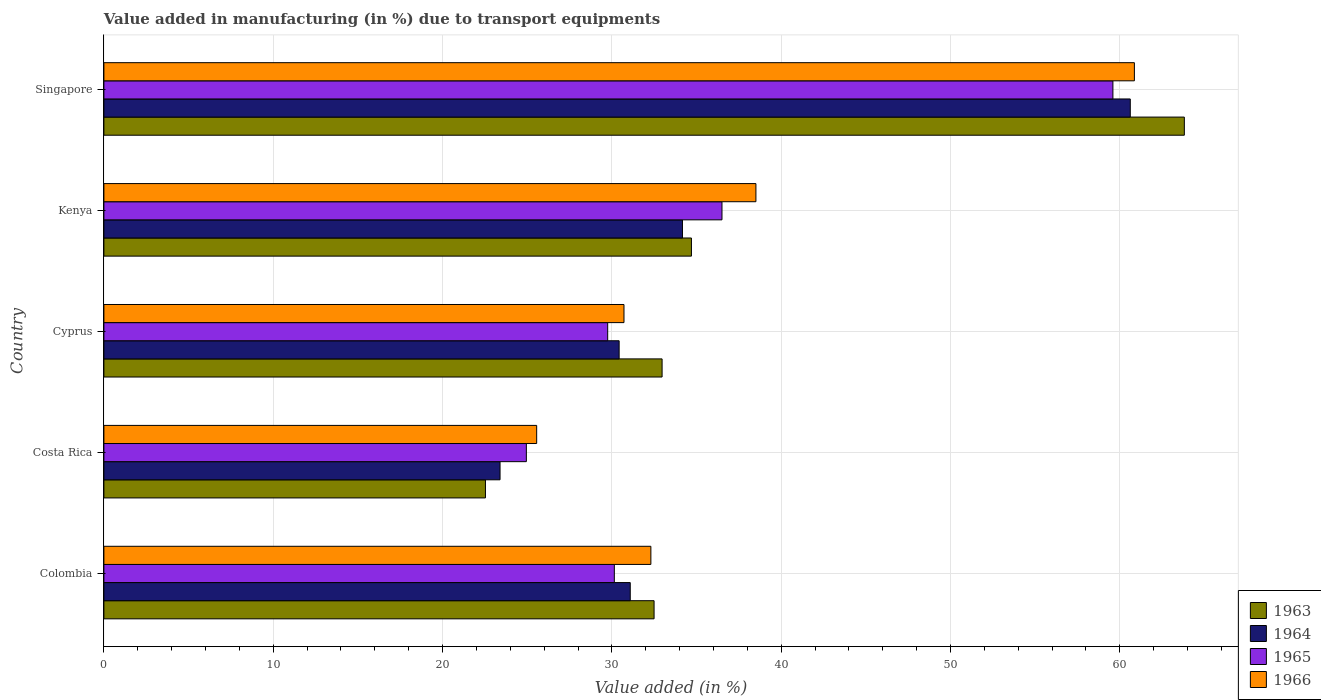Are the number of bars per tick equal to the number of legend labels?
Offer a terse response. Yes. How many bars are there on the 2nd tick from the top?
Ensure brevity in your answer.  4. What is the label of the 2nd group of bars from the top?
Keep it short and to the point. Kenya. What is the percentage of value added in manufacturing due to transport equipments in 1963 in Costa Rica?
Provide a short and direct response. 22.53. Across all countries, what is the maximum percentage of value added in manufacturing due to transport equipments in 1965?
Your response must be concise. 59.59. Across all countries, what is the minimum percentage of value added in manufacturing due to transport equipments in 1965?
Your answer should be very brief. 24.95. In which country was the percentage of value added in manufacturing due to transport equipments in 1965 maximum?
Keep it short and to the point. Singapore. In which country was the percentage of value added in manufacturing due to transport equipments in 1966 minimum?
Your answer should be compact. Costa Rica. What is the total percentage of value added in manufacturing due to transport equipments in 1966 in the graph?
Your answer should be very brief. 187.95. What is the difference between the percentage of value added in manufacturing due to transport equipments in 1964 in Colombia and that in Singapore?
Give a very brief answer. -29.53. What is the difference between the percentage of value added in manufacturing due to transport equipments in 1965 in Colombia and the percentage of value added in manufacturing due to transport equipments in 1963 in Singapore?
Ensure brevity in your answer.  -33.66. What is the average percentage of value added in manufacturing due to transport equipments in 1964 per country?
Offer a very short reply. 35.94. What is the difference between the percentage of value added in manufacturing due to transport equipments in 1963 and percentage of value added in manufacturing due to transport equipments in 1964 in Kenya?
Offer a terse response. 0.53. What is the ratio of the percentage of value added in manufacturing due to transport equipments in 1963 in Cyprus to that in Singapore?
Provide a succinct answer. 0.52. Is the percentage of value added in manufacturing due to transport equipments in 1965 in Colombia less than that in Cyprus?
Give a very brief answer. No. What is the difference between the highest and the second highest percentage of value added in manufacturing due to transport equipments in 1964?
Your answer should be very brief. 26.45. What is the difference between the highest and the lowest percentage of value added in manufacturing due to transport equipments in 1965?
Your answer should be compact. 34.64. In how many countries, is the percentage of value added in manufacturing due to transport equipments in 1966 greater than the average percentage of value added in manufacturing due to transport equipments in 1966 taken over all countries?
Offer a very short reply. 2. Is it the case that in every country, the sum of the percentage of value added in manufacturing due to transport equipments in 1964 and percentage of value added in manufacturing due to transport equipments in 1963 is greater than the sum of percentage of value added in manufacturing due to transport equipments in 1966 and percentage of value added in manufacturing due to transport equipments in 1965?
Offer a terse response. No. What does the 1st bar from the top in Cyprus represents?
Give a very brief answer. 1966. Are all the bars in the graph horizontal?
Provide a short and direct response. Yes. How many countries are there in the graph?
Offer a terse response. 5. What is the difference between two consecutive major ticks on the X-axis?
Ensure brevity in your answer.  10. Are the values on the major ticks of X-axis written in scientific E-notation?
Ensure brevity in your answer.  No. Does the graph contain any zero values?
Your response must be concise. No. How many legend labels are there?
Give a very brief answer. 4. How are the legend labels stacked?
Your answer should be compact. Vertical. What is the title of the graph?
Offer a very short reply. Value added in manufacturing (in %) due to transport equipments. Does "1968" appear as one of the legend labels in the graph?
Offer a very short reply. No. What is the label or title of the X-axis?
Ensure brevity in your answer.  Value added (in %). What is the Value added (in %) of 1963 in Colombia?
Your response must be concise. 32.49. What is the Value added (in %) of 1964 in Colombia?
Give a very brief answer. 31.09. What is the Value added (in %) of 1965 in Colombia?
Make the answer very short. 30.15. What is the Value added (in %) of 1966 in Colombia?
Make the answer very short. 32.3. What is the Value added (in %) of 1963 in Costa Rica?
Give a very brief answer. 22.53. What is the Value added (in %) of 1964 in Costa Rica?
Your response must be concise. 23.4. What is the Value added (in %) of 1965 in Costa Rica?
Give a very brief answer. 24.95. What is the Value added (in %) of 1966 in Costa Rica?
Keep it short and to the point. 25.56. What is the Value added (in %) in 1963 in Cyprus?
Keep it short and to the point. 32.97. What is the Value added (in %) of 1964 in Cyprus?
Ensure brevity in your answer.  30.43. What is the Value added (in %) in 1965 in Cyprus?
Keep it short and to the point. 29.75. What is the Value added (in %) in 1966 in Cyprus?
Provide a succinct answer. 30.72. What is the Value added (in %) of 1963 in Kenya?
Your answer should be very brief. 34.7. What is the Value added (in %) in 1964 in Kenya?
Make the answer very short. 34.17. What is the Value added (in %) in 1965 in Kenya?
Provide a short and direct response. 36.5. What is the Value added (in %) in 1966 in Kenya?
Your answer should be compact. 38.51. What is the Value added (in %) in 1963 in Singapore?
Your answer should be very brief. 63.81. What is the Value added (in %) of 1964 in Singapore?
Your response must be concise. 60.62. What is the Value added (in %) in 1965 in Singapore?
Keep it short and to the point. 59.59. What is the Value added (in %) of 1966 in Singapore?
Give a very brief answer. 60.86. Across all countries, what is the maximum Value added (in %) of 1963?
Your answer should be compact. 63.81. Across all countries, what is the maximum Value added (in %) of 1964?
Your response must be concise. 60.62. Across all countries, what is the maximum Value added (in %) in 1965?
Your response must be concise. 59.59. Across all countries, what is the maximum Value added (in %) in 1966?
Your answer should be very brief. 60.86. Across all countries, what is the minimum Value added (in %) in 1963?
Make the answer very short. 22.53. Across all countries, what is the minimum Value added (in %) in 1964?
Keep it short and to the point. 23.4. Across all countries, what is the minimum Value added (in %) of 1965?
Provide a succinct answer. 24.95. Across all countries, what is the minimum Value added (in %) in 1966?
Provide a succinct answer. 25.56. What is the total Value added (in %) of 1963 in the graph?
Provide a short and direct response. 186.5. What is the total Value added (in %) in 1964 in the graph?
Offer a terse response. 179.7. What is the total Value added (in %) of 1965 in the graph?
Ensure brevity in your answer.  180.94. What is the total Value added (in %) of 1966 in the graph?
Your answer should be very brief. 187.95. What is the difference between the Value added (in %) in 1963 in Colombia and that in Costa Rica?
Give a very brief answer. 9.96. What is the difference between the Value added (in %) in 1964 in Colombia and that in Costa Rica?
Keep it short and to the point. 7.69. What is the difference between the Value added (in %) in 1965 in Colombia and that in Costa Rica?
Your answer should be very brief. 5.2. What is the difference between the Value added (in %) of 1966 in Colombia and that in Costa Rica?
Ensure brevity in your answer.  6.74. What is the difference between the Value added (in %) in 1963 in Colombia and that in Cyprus?
Give a very brief answer. -0.47. What is the difference between the Value added (in %) in 1964 in Colombia and that in Cyprus?
Your answer should be very brief. 0.66. What is the difference between the Value added (in %) of 1965 in Colombia and that in Cyprus?
Offer a terse response. 0.39. What is the difference between the Value added (in %) in 1966 in Colombia and that in Cyprus?
Offer a very short reply. 1.59. What is the difference between the Value added (in %) of 1963 in Colombia and that in Kenya?
Your answer should be compact. -2.21. What is the difference between the Value added (in %) in 1964 in Colombia and that in Kenya?
Ensure brevity in your answer.  -3.08. What is the difference between the Value added (in %) in 1965 in Colombia and that in Kenya?
Offer a very short reply. -6.36. What is the difference between the Value added (in %) of 1966 in Colombia and that in Kenya?
Offer a very short reply. -6.2. What is the difference between the Value added (in %) of 1963 in Colombia and that in Singapore?
Your response must be concise. -31.32. What is the difference between the Value added (in %) in 1964 in Colombia and that in Singapore?
Give a very brief answer. -29.53. What is the difference between the Value added (in %) of 1965 in Colombia and that in Singapore?
Your answer should be compact. -29.45. What is the difference between the Value added (in %) in 1966 in Colombia and that in Singapore?
Ensure brevity in your answer.  -28.56. What is the difference between the Value added (in %) of 1963 in Costa Rica and that in Cyprus?
Give a very brief answer. -10.43. What is the difference between the Value added (in %) in 1964 in Costa Rica and that in Cyprus?
Your answer should be compact. -7.03. What is the difference between the Value added (in %) of 1965 in Costa Rica and that in Cyprus?
Your answer should be very brief. -4.8. What is the difference between the Value added (in %) in 1966 in Costa Rica and that in Cyprus?
Offer a terse response. -5.16. What is the difference between the Value added (in %) of 1963 in Costa Rica and that in Kenya?
Offer a terse response. -12.17. What is the difference between the Value added (in %) of 1964 in Costa Rica and that in Kenya?
Keep it short and to the point. -10.77. What is the difference between the Value added (in %) of 1965 in Costa Rica and that in Kenya?
Make the answer very short. -11.55. What is the difference between the Value added (in %) in 1966 in Costa Rica and that in Kenya?
Offer a very short reply. -12.95. What is the difference between the Value added (in %) in 1963 in Costa Rica and that in Singapore?
Offer a very short reply. -41.28. What is the difference between the Value added (in %) of 1964 in Costa Rica and that in Singapore?
Your answer should be compact. -37.22. What is the difference between the Value added (in %) in 1965 in Costa Rica and that in Singapore?
Make the answer very short. -34.64. What is the difference between the Value added (in %) of 1966 in Costa Rica and that in Singapore?
Your answer should be very brief. -35.3. What is the difference between the Value added (in %) of 1963 in Cyprus and that in Kenya?
Ensure brevity in your answer.  -1.73. What is the difference between the Value added (in %) of 1964 in Cyprus and that in Kenya?
Provide a short and direct response. -3.74. What is the difference between the Value added (in %) of 1965 in Cyprus and that in Kenya?
Offer a terse response. -6.75. What is the difference between the Value added (in %) in 1966 in Cyprus and that in Kenya?
Your response must be concise. -7.79. What is the difference between the Value added (in %) in 1963 in Cyprus and that in Singapore?
Offer a very short reply. -30.84. What is the difference between the Value added (in %) in 1964 in Cyprus and that in Singapore?
Provide a short and direct response. -30.19. What is the difference between the Value added (in %) in 1965 in Cyprus and that in Singapore?
Give a very brief answer. -29.84. What is the difference between the Value added (in %) of 1966 in Cyprus and that in Singapore?
Offer a terse response. -30.14. What is the difference between the Value added (in %) in 1963 in Kenya and that in Singapore?
Give a very brief answer. -29.11. What is the difference between the Value added (in %) in 1964 in Kenya and that in Singapore?
Ensure brevity in your answer.  -26.45. What is the difference between the Value added (in %) of 1965 in Kenya and that in Singapore?
Your answer should be very brief. -23.09. What is the difference between the Value added (in %) of 1966 in Kenya and that in Singapore?
Provide a short and direct response. -22.35. What is the difference between the Value added (in %) in 1963 in Colombia and the Value added (in %) in 1964 in Costa Rica?
Ensure brevity in your answer.  9.1. What is the difference between the Value added (in %) of 1963 in Colombia and the Value added (in %) of 1965 in Costa Rica?
Provide a short and direct response. 7.54. What is the difference between the Value added (in %) of 1963 in Colombia and the Value added (in %) of 1966 in Costa Rica?
Provide a succinct answer. 6.93. What is the difference between the Value added (in %) in 1964 in Colombia and the Value added (in %) in 1965 in Costa Rica?
Make the answer very short. 6.14. What is the difference between the Value added (in %) of 1964 in Colombia and the Value added (in %) of 1966 in Costa Rica?
Your answer should be compact. 5.53. What is the difference between the Value added (in %) of 1965 in Colombia and the Value added (in %) of 1966 in Costa Rica?
Provide a succinct answer. 4.59. What is the difference between the Value added (in %) in 1963 in Colombia and the Value added (in %) in 1964 in Cyprus?
Keep it short and to the point. 2.06. What is the difference between the Value added (in %) of 1963 in Colombia and the Value added (in %) of 1965 in Cyprus?
Keep it short and to the point. 2.74. What is the difference between the Value added (in %) of 1963 in Colombia and the Value added (in %) of 1966 in Cyprus?
Make the answer very short. 1.78. What is the difference between the Value added (in %) in 1964 in Colombia and the Value added (in %) in 1965 in Cyprus?
Keep it short and to the point. 1.33. What is the difference between the Value added (in %) of 1964 in Colombia and the Value added (in %) of 1966 in Cyprus?
Offer a very short reply. 0.37. What is the difference between the Value added (in %) in 1965 in Colombia and the Value added (in %) in 1966 in Cyprus?
Offer a very short reply. -0.57. What is the difference between the Value added (in %) in 1963 in Colombia and the Value added (in %) in 1964 in Kenya?
Ensure brevity in your answer.  -1.68. What is the difference between the Value added (in %) in 1963 in Colombia and the Value added (in %) in 1965 in Kenya?
Your response must be concise. -4.01. What is the difference between the Value added (in %) in 1963 in Colombia and the Value added (in %) in 1966 in Kenya?
Keep it short and to the point. -6.01. What is the difference between the Value added (in %) in 1964 in Colombia and the Value added (in %) in 1965 in Kenya?
Give a very brief answer. -5.42. What is the difference between the Value added (in %) of 1964 in Colombia and the Value added (in %) of 1966 in Kenya?
Offer a very short reply. -7.42. What is the difference between the Value added (in %) in 1965 in Colombia and the Value added (in %) in 1966 in Kenya?
Your answer should be very brief. -8.36. What is the difference between the Value added (in %) in 1963 in Colombia and the Value added (in %) in 1964 in Singapore?
Provide a succinct answer. -28.12. What is the difference between the Value added (in %) in 1963 in Colombia and the Value added (in %) in 1965 in Singapore?
Provide a short and direct response. -27.1. What is the difference between the Value added (in %) of 1963 in Colombia and the Value added (in %) of 1966 in Singapore?
Give a very brief answer. -28.37. What is the difference between the Value added (in %) in 1964 in Colombia and the Value added (in %) in 1965 in Singapore?
Keep it short and to the point. -28.51. What is the difference between the Value added (in %) in 1964 in Colombia and the Value added (in %) in 1966 in Singapore?
Offer a very short reply. -29.77. What is the difference between the Value added (in %) in 1965 in Colombia and the Value added (in %) in 1966 in Singapore?
Keep it short and to the point. -30.71. What is the difference between the Value added (in %) in 1963 in Costa Rica and the Value added (in %) in 1964 in Cyprus?
Offer a very short reply. -7.9. What is the difference between the Value added (in %) in 1963 in Costa Rica and the Value added (in %) in 1965 in Cyprus?
Make the answer very short. -7.22. What is the difference between the Value added (in %) in 1963 in Costa Rica and the Value added (in %) in 1966 in Cyprus?
Make the answer very short. -8.18. What is the difference between the Value added (in %) in 1964 in Costa Rica and the Value added (in %) in 1965 in Cyprus?
Ensure brevity in your answer.  -6.36. What is the difference between the Value added (in %) of 1964 in Costa Rica and the Value added (in %) of 1966 in Cyprus?
Ensure brevity in your answer.  -7.32. What is the difference between the Value added (in %) in 1965 in Costa Rica and the Value added (in %) in 1966 in Cyprus?
Provide a short and direct response. -5.77. What is the difference between the Value added (in %) in 1963 in Costa Rica and the Value added (in %) in 1964 in Kenya?
Provide a short and direct response. -11.64. What is the difference between the Value added (in %) in 1963 in Costa Rica and the Value added (in %) in 1965 in Kenya?
Ensure brevity in your answer.  -13.97. What is the difference between the Value added (in %) in 1963 in Costa Rica and the Value added (in %) in 1966 in Kenya?
Provide a succinct answer. -15.97. What is the difference between the Value added (in %) of 1964 in Costa Rica and the Value added (in %) of 1965 in Kenya?
Offer a terse response. -13.11. What is the difference between the Value added (in %) in 1964 in Costa Rica and the Value added (in %) in 1966 in Kenya?
Provide a short and direct response. -15.11. What is the difference between the Value added (in %) in 1965 in Costa Rica and the Value added (in %) in 1966 in Kenya?
Offer a terse response. -13.56. What is the difference between the Value added (in %) of 1963 in Costa Rica and the Value added (in %) of 1964 in Singapore?
Make the answer very short. -38.08. What is the difference between the Value added (in %) of 1963 in Costa Rica and the Value added (in %) of 1965 in Singapore?
Your answer should be very brief. -37.06. What is the difference between the Value added (in %) of 1963 in Costa Rica and the Value added (in %) of 1966 in Singapore?
Give a very brief answer. -38.33. What is the difference between the Value added (in %) in 1964 in Costa Rica and the Value added (in %) in 1965 in Singapore?
Make the answer very short. -36.19. What is the difference between the Value added (in %) in 1964 in Costa Rica and the Value added (in %) in 1966 in Singapore?
Offer a very short reply. -37.46. What is the difference between the Value added (in %) of 1965 in Costa Rica and the Value added (in %) of 1966 in Singapore?
Ensure brevity in your answer.  -35.91. What is the difference between the Value added (in %) in 1963 in Cyprus and the Value added (in %) in 1964 in Kenya?
Your answer should be very brief. -1.2. What is the difference between the Value added (in %) of 1963 in Cyprus and the Value added (in %) of 1965 in Kenya?
Your answer should be compact. -3.54. What is the difference between the Value added (in %) in 1963 in Cyprus and the Value added (in %) in 1966 in Kenya?
Your answer should be very brief. -5.54. What is the difference between the Value added (in %) in 1964 in Cyprus and the Value added (in %) in 1965 in Kenya?
Provide a short and direct response. -6.07. What is the difference between the Value added (in %) of 1964 in Cyprus and the Value added (in %) of 1966 in Kenya?
Provide a short and direct response. -8.08. What is the difference between the Value added (in %) in 1965 in Cyprus and the Value added (in %) in 1966 in Kenya?
Provide a succinct answer. -8.75. What is the difference between the Value added (in %) in 1963 in Cyprus and the Value added (in %) in 1964 in Singapore?
Ensure brevity in your answer.  -27.65. What is the difference between the Value added (in %) in 1963 in Cyprus and the Value added (in %) in 1965 in Singapore?
Provide a succinct answer. -26.62. What is the difference between the Value added (in %) in 1963 in Cyprus and the Value added (in %) in 1966 in Singapore?
Provide a succinct answer. -27.89. What is the difference between the Value added (in %) of 1964 in Cyprus and the Value added (in %) of 1965 in Singapore?
Offer a very short reply. -29.16. What is the difference between the Value added (in %) in 1964 in Cyprus and the Value added (in %) in 1966 in Singapore?
Ensure brevity in your answer.  -30.43. What is the difference between the Value added (in %) in 1965 in Cyprus and the Value added (in %) in 1966 in Singapore?
Make the answer very short. -31.11. What is the difference between the Value added (in %) in 1963 in Kenya and the Value added (in %) in 1964 in Singapore?
Provide a succinct answer. -25.92. What is the difference between the Value added (in %) of 1963 in Kenya and the Value added (in %) of 1965 in Singapore?
Offer a very short reply. -24.89. What is the difference between the Value added (in %) in 1963 in Kenya and the Value added (in %) in 1966 in Singapore?
Provide a short and direct response. -26.16. What is the difference between the Value added (in %) in 1964 in Kenya and the Value added (in %) in 1965 in Singapore?
Your answer should be compact. -25.42. What is the difference between the Value added (in %) in 1964 in Kenya and the Value added (in %) in 1966 in Singapore?
Offer a terse response. -26.69. What is the difference between the Value added (in %) of 1965 in Kenya and the Value added (in %) of 1966 in Singapore?
Give a very brief answer. -24.36. What is the average Value added (in %) in 1963 per country?
Provide a short and direct response. 37.3. What is the average Value added (in %) in 1964 per country?
Ensure brevity in your answer.  35.94. What is the average Value added (in %) in 1965 per country?
Offer a very short reply. 36.19. What is the average Value added (in %) in 1966 per country?
Provide a succinct answer. 37.59. What is the difference between the Value added (in %) of 1963 and Value added (in %) of 1964 in Colombia?
Your answer should be compact. 1.41. What is the difference between the Value added (in %) of 1963 and Value added (in %) of 1965 in Colombia?
Your answer should be compact. 2.35. What is the difference between the Value added (in %) of 1963 and Value added (in %) of 1966 in Colombia?
Ensure brevity in your answer.  0.19. What is the difference between the Value added (in %) of 1964 and Value added (in %) of 1965 in Colombia?
Your response must be concise. 0.94. What is the difference between the Value added (in %) in 1964 and Value added (in %) in 1966 in Colombia?
Provide a short and direct response. -1.22. What is the difference between the Value added (in %) of 1965 and Value added (in %) of 1966 in Colombia?
Your response must be concise. -2.16. What is the difference between the Value added (in %) in 1963 and Value added (in %) in 1964 in Costa Rica?
Provide a short and direct response. -0.86. What is the difference between the Value added (in %) of 1963 and Value added (in %) of 1965 in Costa Rica?
Ensure brevity in your answer.  -2.42. What is the difference between the Value added (in %) in 1963 and Value added (in %) in 1966 in Costa Rica?
Your answer should be compact. -3.03. What is the difference between the Value added (in %) in 1964 and Value added (in %) in 1965 in Costa Rica?
Provide a short and direct response. -1.55. What is the difference between the Value added (in %) in 1964 and Value added (in %) in 1966 in Costa Rica?
Ensure brevity in your answer.  -2.16. What is the difference between the Value added (in %) in 1965 and Value added (in %) in 1966 in Costa Rica?
Your response must be concise. -0.61. What is the difference between the Value added (in %) of 1963 and Value added (in %) of 1964 in Cyprus?
Provide a short and direct response. 2.54. What is the difference between the Value added (in %) in 1963 and Value added (in %) in 1965 in Cyprus?
Provide a succinct answer. 3.21. What is the difference between the Value added (in %) of 1963 and Value added (in %) of 1966 in Cyprus?
Provide a short and direct response. 2.25. What is the difference between the Value added (in %) in 1964 and Value added (in %) in 1965 in Cyprus?
Give a very brief answer. 0.68. What is the difference between the Value added (in %) of 1964 and Value added (in %) of 1966 in Cyprus?
Offer a very short reply. -0.29. What is the difference between the Value added (in %) in 1965 and Value added (in %) in 1966 in Cyprus?
Your response must be concise. -0.96. What is the difference between the Value added (in %) of 1963 and Value added (in %) of 1964 in Kenya?
Provide a succinct answer. 0.53. What is the difference between the Value added (in %) of 1963 and Value added (in %) of 1965 in Kenya?
Your answer should be very brief. -1.8. What is the difference between the Value added (in %) of 1963 and Value added (in %) of 1966 in Kenya?
Give a very brief answer. -3.81. What is the difference between the Value added (in %) in 1964 and Value added (in %) in 1965 in Kenya?
Ensure brevity in your answer.  -2.33. What is the difference between the Value added (in %) of 1964 and Value added (in %) of 1966 in Kenya?
Keep it short and to the point. -4.34. What is the difference between the Value added (in %) of 1965 and Value added (in %) of 1966 in Kenya?
Keep it short and to the point. -2. What is the difference between the Value added (in %) in 1963 and Value added (in %) in 1964 in Singapore?
Your response must be concise. 3.19. What is the difference between the Value added (in %) of 1963 and Value added (in %) of 1965 in Singapore?
Give a very brief answer. 4.22. What is the difference between the Value added (in %) in 1963 and Value added (in %) in 1966 in Singapore?
Your response must be concise. 2.95. What is the difference between the Value added (in %) in 1964 and Value added (in %) in 1965 in Singapore?
Your answer should be very brief. 1.03. What is the difference between the Value added (in %) of 1964 and Value added (in %) of 1966 in Singapore?
Provide a succinct answer. -0.24. What is the difference between the Value added (in %) of 1965 and Value added (in %) of 1966 in Singapore?
Keep it short and to the point. -1.27. What is the ratio of the Value added (in %) of 1963 in Colombia to that in Costa Rica?
Give a very brief answer. 1.44. What is the ratio of the Value added (in %) of 1964 in Colombia to that in Costa Rica?
Ensure brevity in your answer.  1.33. What is the ratio of the Value added (in %) of 1965 in Colombia to that in Costa Rica?
Offer a very short reply. 1.21. What is the ratio of the Value added (in %) in 1966 in Colombia to that in Costa Rica?
Provide a short and direct response. 1.26. What is the ratio of the Value added (in %) of 1963 in Colombia to that in Cyprus?
Give a very brief answer. 0.99. What is the ratio of the Value added (in %) of 1964 in Colombia to that in Cyprus?
Provide a succinct answer. 1.02. What is the ratio of the Value added (in %) of 1965 in Colombia to that in Cyprus?
Your answer should be very brief. 1.01. What is the ratio of the Value added (in %) of 1966 in Colombia to that in Cyprus?
Offer a terse response. 1.05. What is the ratio of the Value added (in %) in 1963 in Colombia to that in Kenya?
Your response must be concise. 0.94. What is the ratio of the Value added (in %) of 1964 in Colombia to that in Kenya?
Make the answer very short. 0.91. What is the ratio of the Value added (in %) of 1965 in Colombia to that in Kenya?
Keep it short and to the point. 0.83. What is the ratio of the Value added (in %) in 1966 in Colombia to that in Kenya?
Your answer should be compact. 0.84. What is the ratio of the Value added (in %) of 1963 in Colombia to that in Singapore?
Provide a succinct answer. 0.51. What is the ratio of the Value added (in %) in 1964 in Colombia to that in Singapore?
Make the answer very short. 0.51. What is the ratio of the Value added (in %) of 1965 in Colombia to that in Singapore?
Offer a very short reply. 0.51. What is the ratio of the Value added (in %) of 1966 in Colombia to that in Singapore?
Your response must be concise. 0.53. What is the ratio of the Value added (in %) of 1963 in Costa Rica to that in Cyprus?
Your response must be concise. 0.68. What is the ratio of the Value added (in %) of 1964 in Costa Rica to that in Cyprus?
Provide a succinct answer. 0.77. What is the ratio of the Value added (in %) of 1965 in Costa Rica to that in Cyprus?
Offer a terse response. 0.84. What is the ratio of the Value added (in %) in 1966 in Costa Rica to that in Cyprus?
Provide a succinct answer. 0.83. What is the ratio of the Value added (in %) of 1963 in Costa Rica to that in Kenya?
Offer a terse response. 0.65. What is the ratio of the Value added (in %) of 1964 in Costa Rica to that in Kenya?
Provide a succinct answer. 0.68. What is the ratio of the Value added (in %) in 1965 in Costa Rica to that in Kenya?
Your answer should be very brief. 0.68. What is the ratio of the Value added (in %) of 1966 in Costa Rica to that in Kenya?
Offer a terse response. 0.66. What is the ratio of the Value added (in %) in 1963 in Costa Rica to that in Singapore?
Your answer should be very brief. 0.35. What is the ratio of the Value added (in %) of 1964 in Costa Rica to that in Singapore?
Offer a very short reply. 0.39. What is the ratio of the Value added (in %) in 1965 in Costa Rica to that in Singapore?
Keep it short and to the point. 0.42. What is the ratio of the Value added (in %) in 1966 in Costa Rica to that in Singapore?
Provide a succinct answer. 0.42. What is the ratio of the Value added (in %) of 1963 in Cyprus to that in Kenya?
Make the answer very short. 0.95. What is the ratio of the Value added (in %) of 1964 in Cyprus to that in Kenya?
Offer a terse response. 0.89. What is the ratio of the Value added (in %) of 1965 in Cyprus to that in Kenya?
Your answer should be very brief. 0.82. What is the ratio of the Value added (in %) in 1966 in Cyprus to that in Kenya?
Ensure brevity in your answer.  0.8. What is the ratio of the Value added (in %) in 1963 in Cyprus to that in Singapore?
Provide a succinct answer. 0.52. What is the ratio of the Value added (in %) in 1964 in Cyprus to that in Singapore?
Your answer should be compact. 0.5. What is the ratio of the Value added (in %) in 1965 in Cyprus to that in Singapore?
Offer a terse response. 0.5. What is the ratio of the Value added (in %) in 1966 in Cyprus to that in Singapore?
Provide a succinct answer. 0.5. What is the ratio of the Value added (in %) of 1963 in Kenya to that in Singapore?
Your answer should be compact. 0.54. What is the ratio of the Value added (in %) of 1964 in Kenya to that in Singapore?
Give a very brief answer. 0.56. What is the ratio of the Value added (in %) in 1965 in Kenya to that in Singapore?
Offer a very short reply. 0.61. What is the ratio of the Value added (in %) in 1966 in Kenya to that in Singapore?
Ensure brevity in your answer.  0.63. What is the difference between the highest and the second highest Value added (in %) in 1963?
Your response must be concise. 29.11. What is the difference between the highest and the second highest Value added (in %) of 1964?
Provide a succinct answer. 26.45. What is the difference between the highest and the second highest Value added (in %) of 1965?
Offer a very short reply. 23.09. What is the difference between the highest and the second highest Value added (in %) of 1966?
Provide a succinct answer. 22.35. What is the difference between the highest and the lowest Value added (in %) in 1963?
Your answer should be very brief. 41.28. What is the difference between the highest and the lowest Value added (in %) of 1964?
Offer a very short reply. 37.22. What is the difference between the highest and the lowest Value added (in %) of 1965?
Give a very brief answer. 34.64. What is the difference between the highest and the lowest Value added (in %) in 1966?
Give a very brief answer. 35.3. 